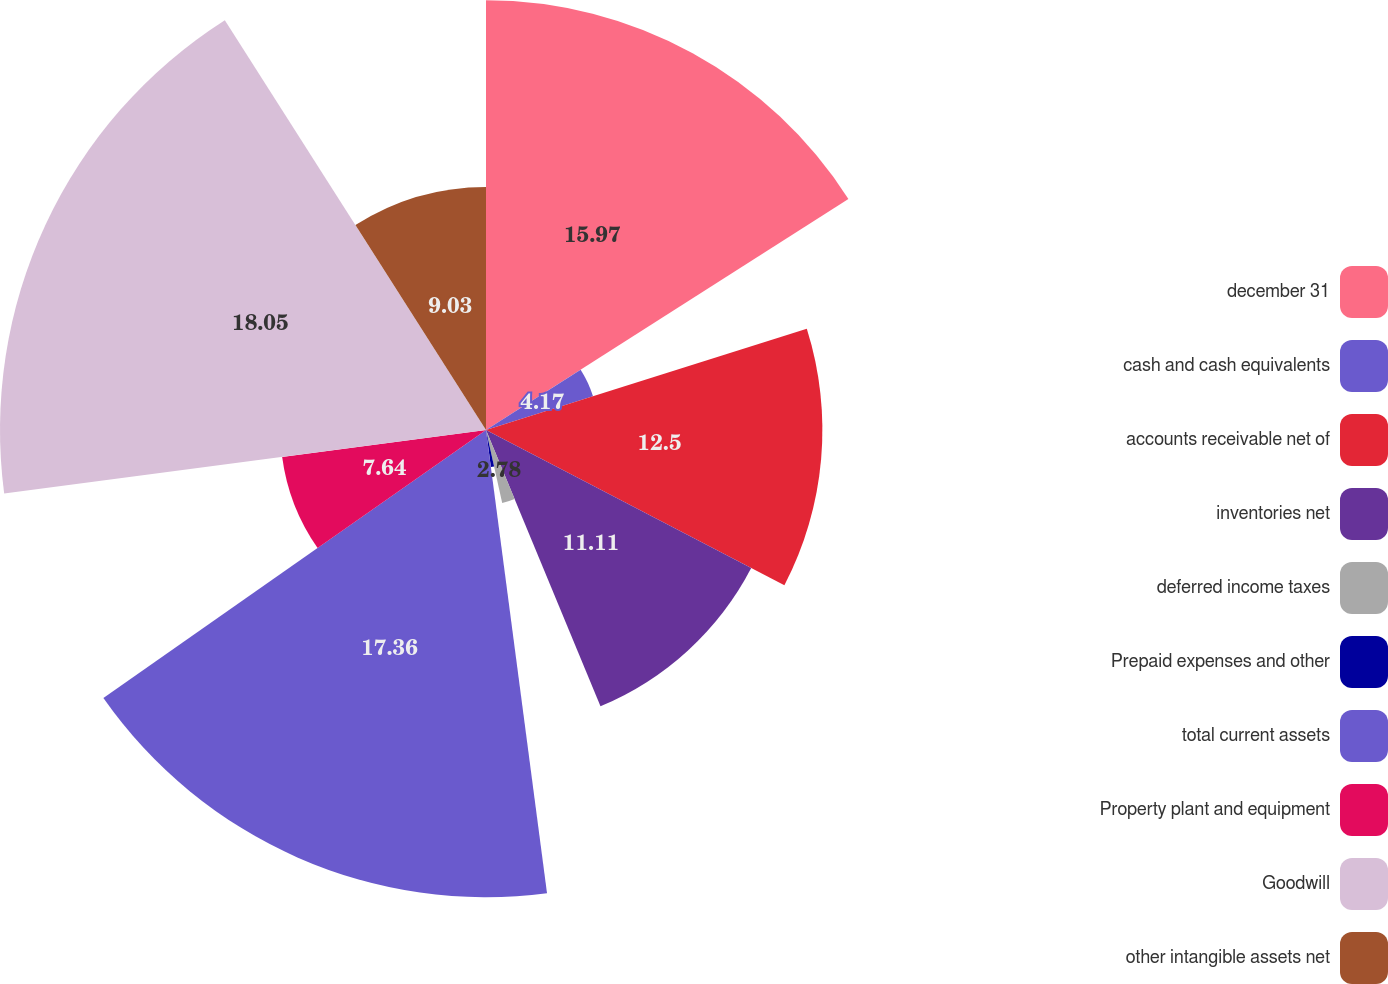Convert chart to OTSL. <chart><loc_0><loc_0><loc_500><loc_500><pie_chart><fcel>december 31<fcel>cash and cash equivalents<fcel>accounts receivable net of<fcel>inventories net<fcel>deferred income taxes<fcel>Prepaid expenses and other<fcel>total current assets<fcel>Property plant and equipment<fcel>Goodwill<fcel>other intangible assets net<nl><fcel>15.97%<fcel>4.17%<fcel>12.5%<fcel>11.11%<fcel>2.78%<fcel>1.39%<fcel>17.36%<fcel>7.64%<fcel>18.06%<fcel>9.03%<nl></chart> 